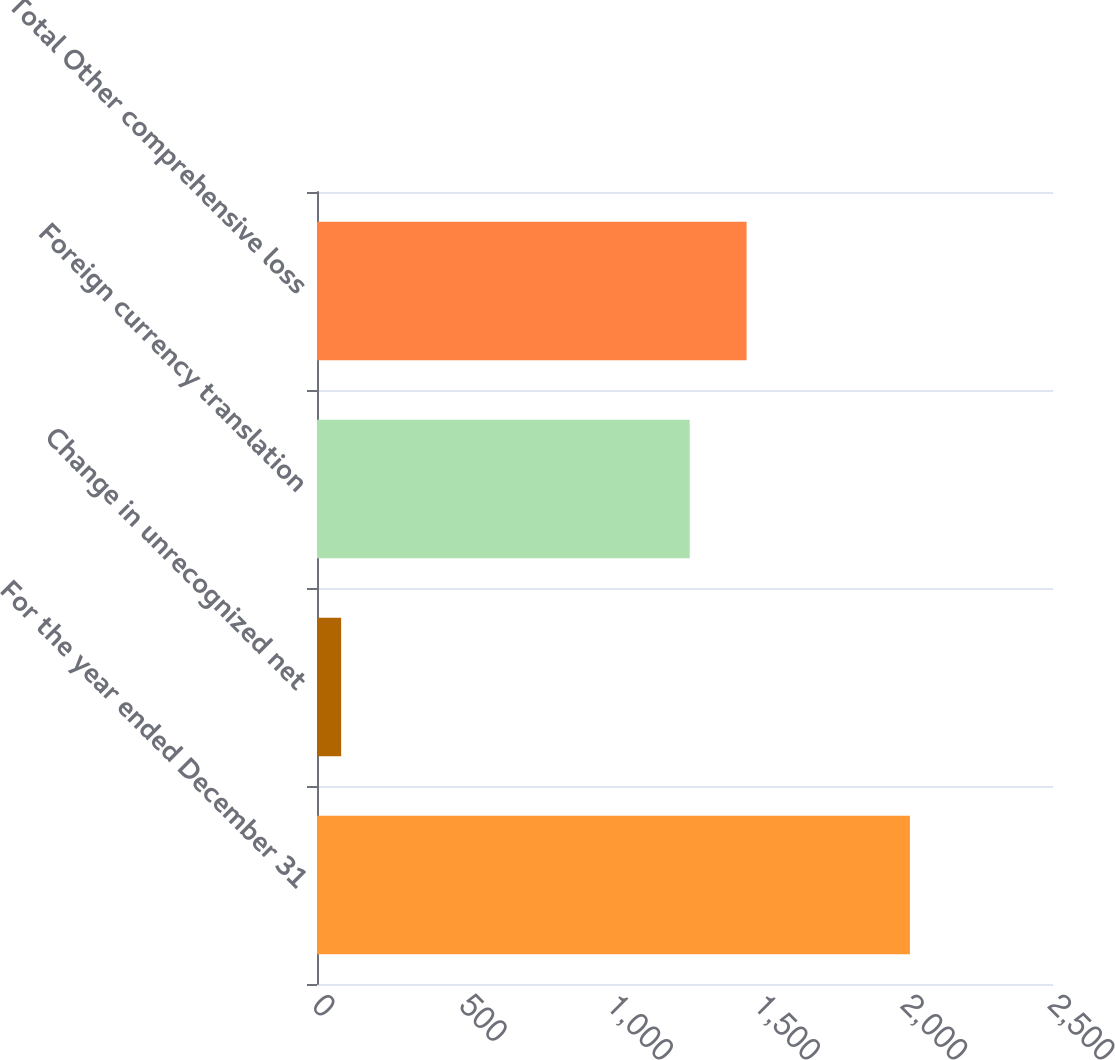Convert chart to OTSL. <chart><loc_0><loc_0><loc_500><loc_500><bar_chart><fcel>For the year ended December 31<fcel>Change in unrecognized net<fcel>Foreign currency translation<fcel>Total Other comprehensive loss<nl><fcel>2014<fcel>82<fcel>1266<fcel>1459.2<nl></chart> 